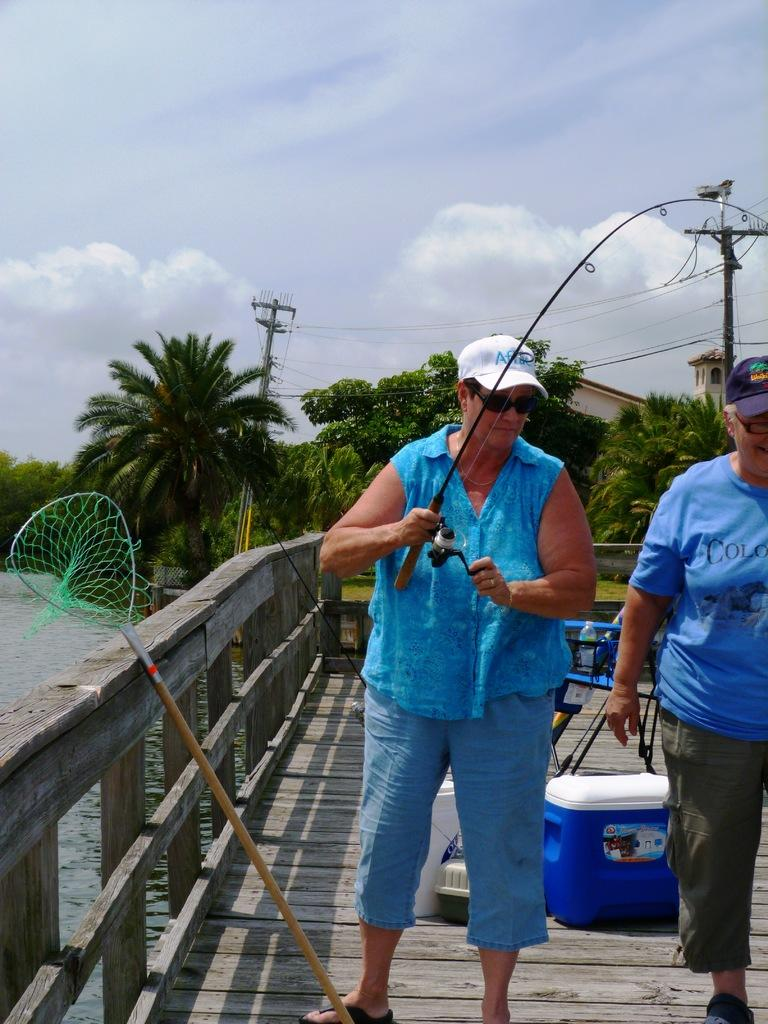What is the condition of the sky in the image? The sky is cloudy in the image. Can you describe the people in the image? There are people in the image, but their specific actions or characteristics are not mentioned in the facts. What can be seen in the background of the image? There are trees, current poles, water, and other objects visible in the background of the image. Can you see any ghosts interacting with the people in the image? There is no mention of ghosts in the image, so it cannot be determined if any are present. What type of action are the people performing in the image? The facts do not specify any particular action the people are performing in the image. 